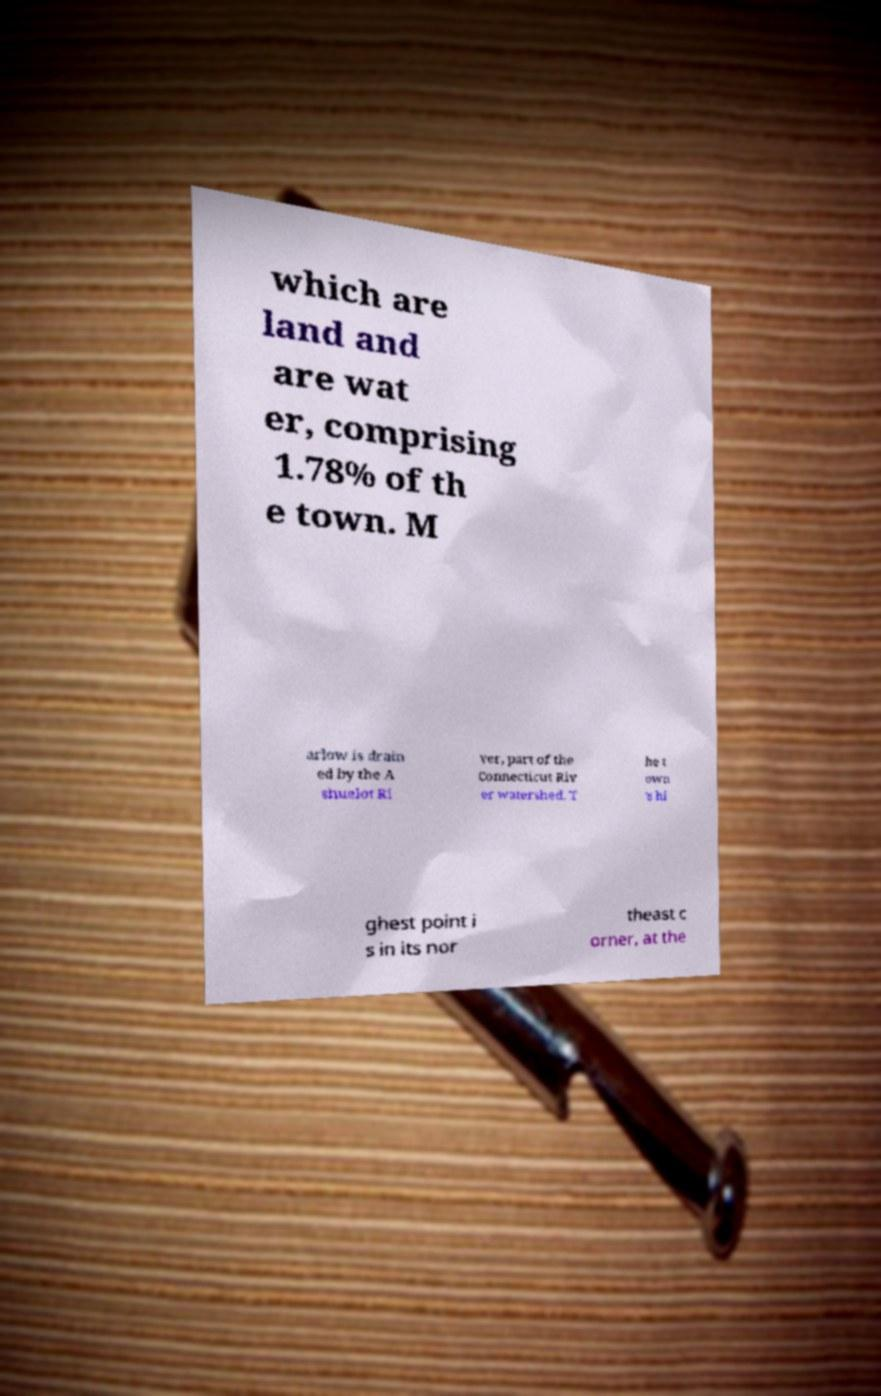Could you assist in decoding the text presented in this image and type it out clearly? which are land and are wat er, comprising 1.78% of th e town. M arlow is drain ed by the A shuelot Ri ver, part of the Connecticut Riv er watershed. T he t own 's hi ghest point i s in its nor theast c orner, at the 